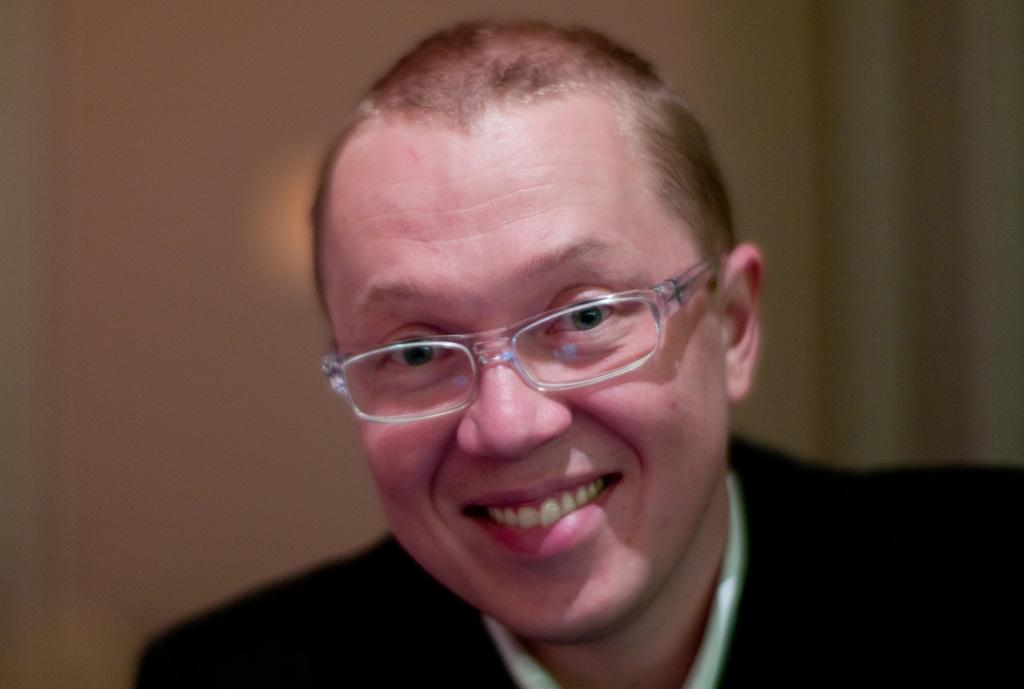What is the main subject of the image? There is a person in the image. What type of clothing is the person wearing on their upper body? The person is wearing a black blazer and a white shirt. What color is the background of the image? The background of the image is cream-colored. What part of the country is depicted in the image? The image does not depict a specific part of a country; it features a person wearing a black blazer and a white shirt against a cream-colored background. 